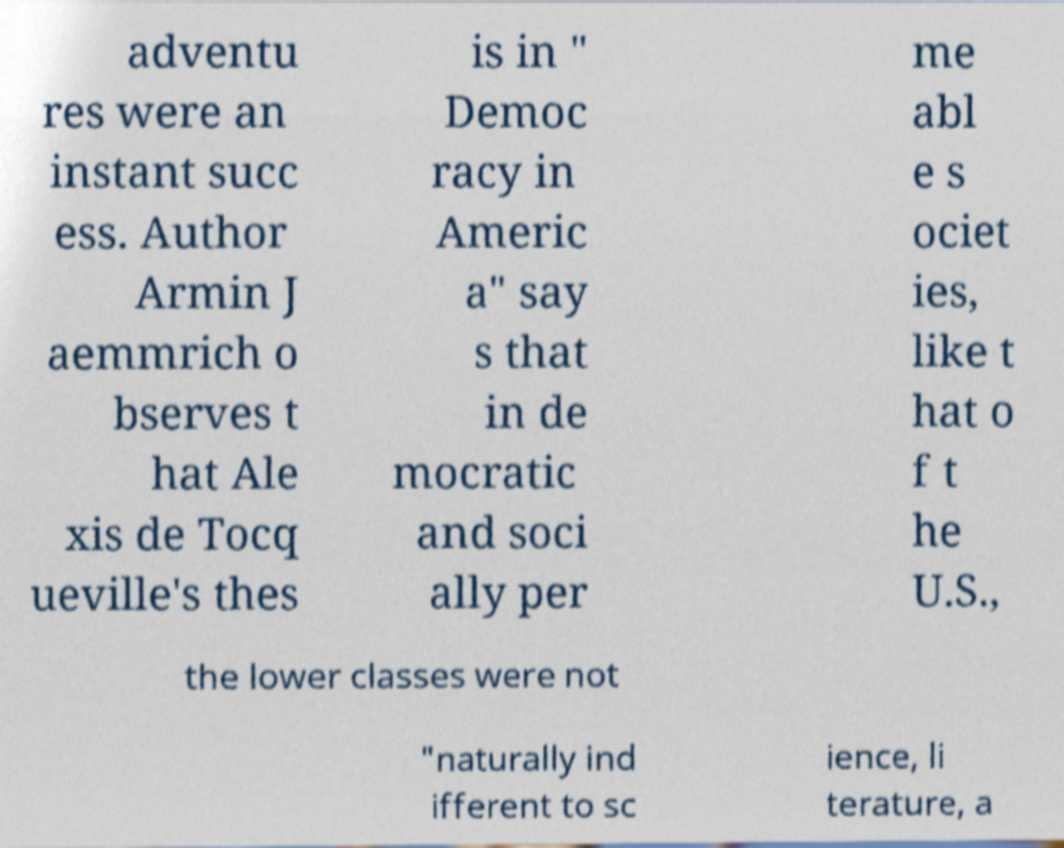For documentation purposes, I need the text within this image transcribed. Could you provide that? adventu res were an instant succ ess. Author Armin J aemmrich o bserves t hat Ale xis de Tocq ueville's thes is in " Democ racy in Americ a" say s that in de mocratic and soci ally per me abl e s ociet ies, like t hat o f t he U.S., the lower classes were not "naturally ind ifferent to sc ience, li terature, a 